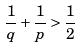Convert formula to latex. <formula><loc_0><loc_0><loc_500><loc_500>\frac { 1 } { q } + \frac { 1 } { p } > \frac { 1 } { 2 }</formula> 